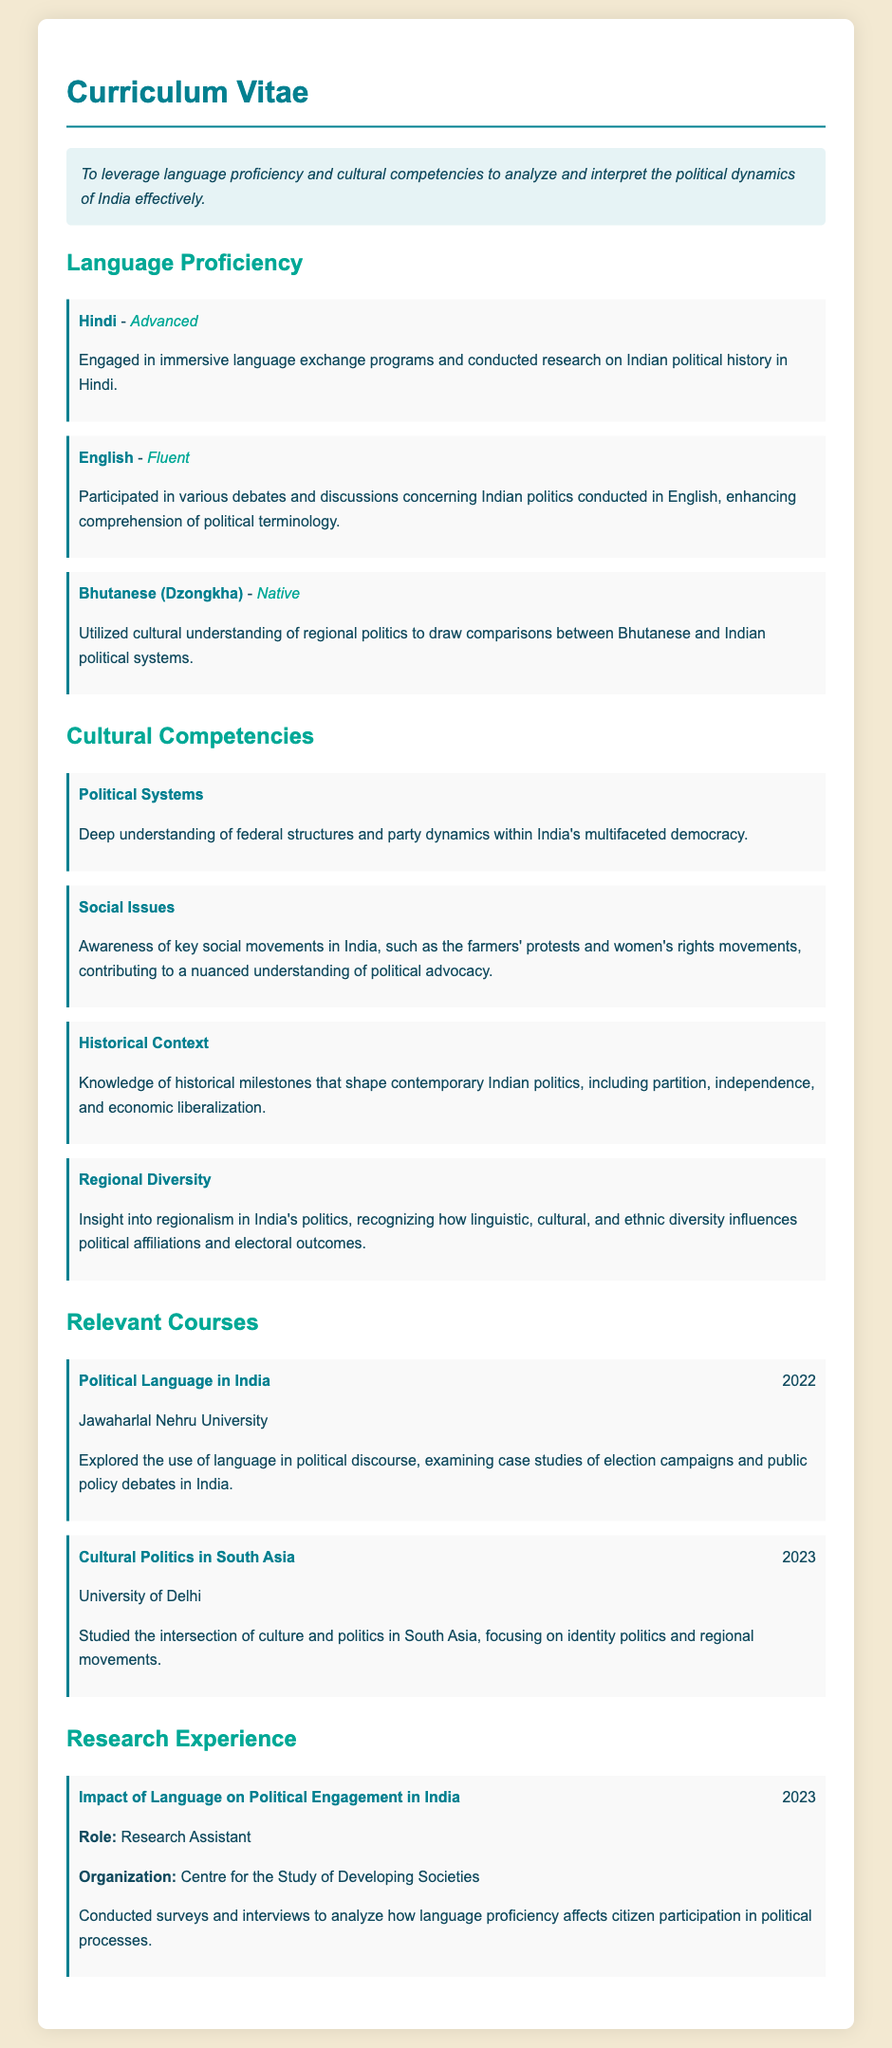What is the individual's objective? The objective states the intent to leverage language proficiency and cultural competencies in analyzing and interpreting political dynamics in India.
Answer: To leverage language proficiency and cultural competencies to analyze and interpret the political dynamics of India effectively Which language is listed as being spoken at a native level? The document specifies that Bhutanese (Dzongkha) is the language spoken at a native level.
Answer: Bhutanese (Dzongkha) What year was the course "Political Language in India" taken? The course titled "Political Language in India" was taken in the year 2022.
Answer: 2022 What is the proficiency level for Hindi? The document indicates that Hindi is mastered to an advanced level.
Answer: Advanced What organization was associated with the research titled "Impact of Language on Political Engagement in India"? The research was conducted under the Centre for the Study of Developing Societies.
Answer: Centre for the Study of Developing Societies Which social movement is highlighted in the document? The document mentions the farmers' protests as a significant social movement in India.
Answer: farmers' protests What type of courses are listed in the CV? The courses presented in the CV focus on political language and cultural politics in South Asia.
Answer: political language and cultural politics How does the individual utilize their cultural understanding of regional politics? The individual draws comparisons between Bhutanese and Indian political systems as a way to utilize cultural understanding.
Answer: draw comparisons between Bhutanese and Indian political systems What are the two language proficiencies reported to be fluent? The individual reports fluency in both English and Hindi.
Answer: English and Hindi 